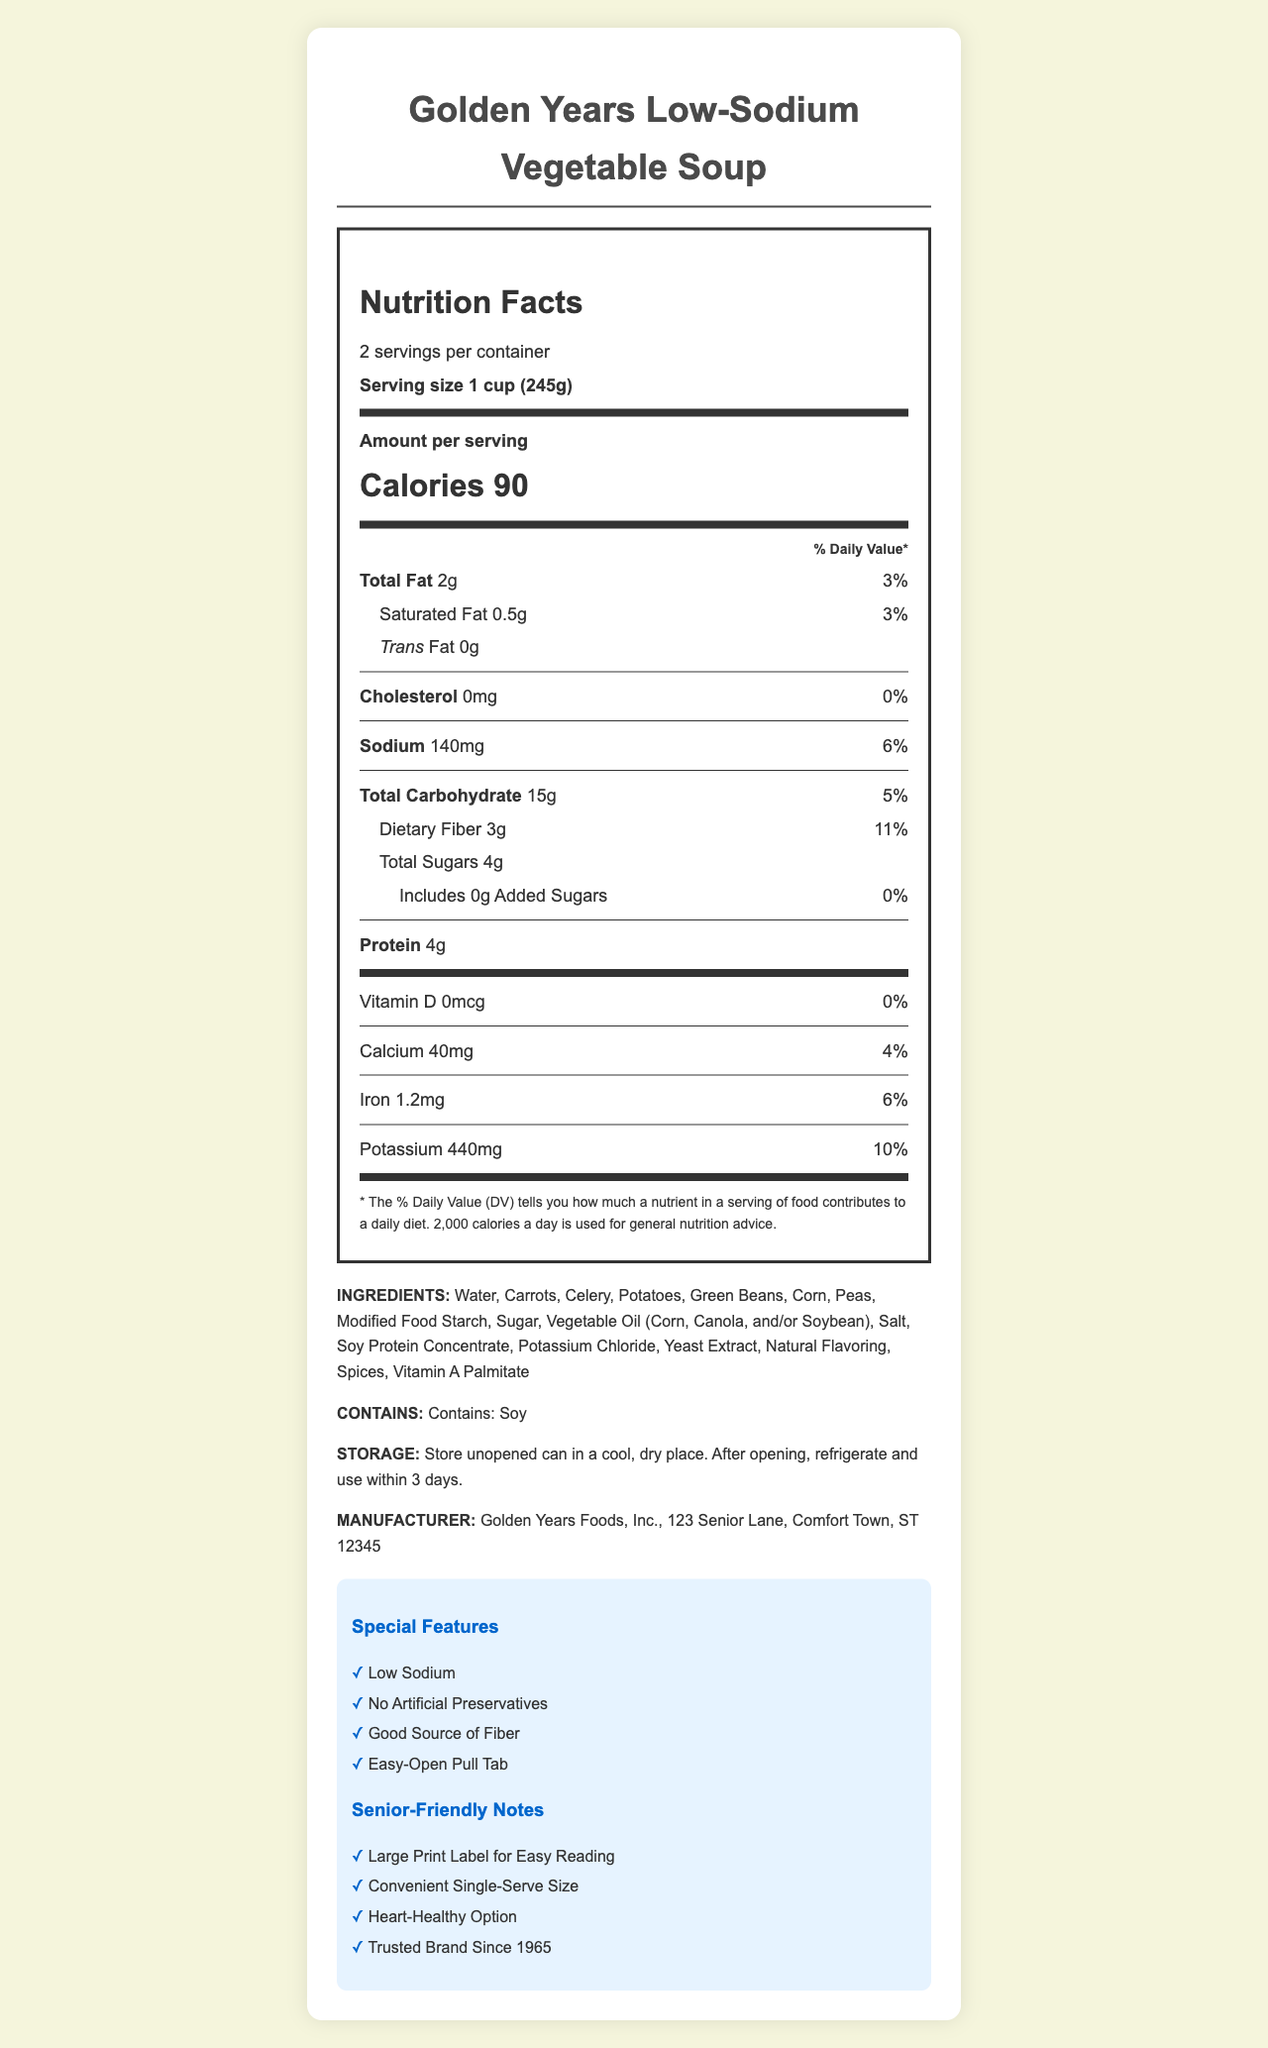what is the serving size? The serving size is clearly listed under the Nutrition Facts section.
Answer: 1 cup (245g) how many calories are in one serving? The number of calories per serving is prominently displayed in the Nutrition Facts section.
Answer: 90 what is the percentage of daily value for sodium? The percentage of daily value for sodium is specified next to the sodium content in the Nutrition Facts.
Answer: 6% which ingredient in the soup is an allergen? The ingredient section clearly mentions that the soup contains soy, making it an allergen.
Answer: Soy where is the manufacturer located? The manufacturer information is listed at the bottom of the document.
Answer: 123 Senior Lane, Comfort Town, ST 12345 what type of fat has 0 grams? The Nutrition Facts label shows that Trans Fat has 0 grams.
Answer: Trans Fat how much dietary fiber does one serving contain? The amount of dietary fiber per serving is listed in the Nutrition Facts section.
Answer: 3g how many servings are in one container? A. 1 B. 2 C. 3 D. 4 The document specifies that there are 2 servings per container.
Answer: B which vitamin has a 0% daily value? A. Vitamin D B. Calcium C. Iron D. Potassium Vitamin D is listed with a 0% daily value.
Answer: A does this product contain any added sugars? The Nutrition Facts section indicates that there are 0 grams of added sugars.
Answer: No is the soup low in sodium? The document specifies "Low Sodium" as one of the special features of the product.
Answer: Yes what features make this product senior-friendly? These features are listed under the "Senior-Friendly Notes" section of the document.
Answer: Large Print Label for Easy Reading, Convenient Single-Serve Size, Heart-Healthy Option, Trusted Brand Since 1965 what is the main idea of the document? The document is a complete overview containing multiple sections addressing nutritional content, product features, and additional pertinent details catered to seniors.
Answer: The document provides detailed nutrition facts, ingredients, allergen information, storage instructions, manufacturer details, and highlights special features and senior-friendly notes for Golden Years Low-Sodium Vegetable Soup. what is the price of the soup? The document does not provide any information about the price of the soup.
Answer: Cannot be determined 